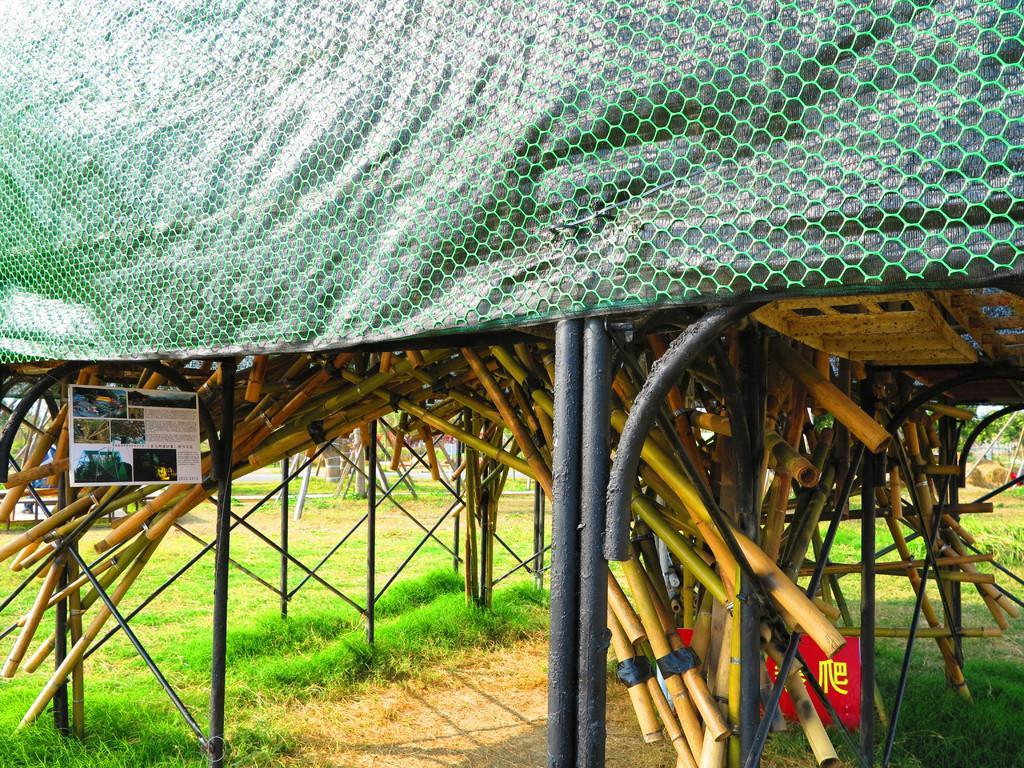Please provide a concise description of this image. In the image there is grass on the land with a tent above it with bamboo sticks mounted in it. 